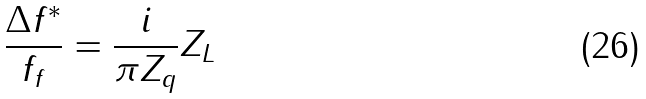Convert formula to latex. <formula><loc_0><loc_0><loc_500><loc_500>\frac { \Delta f ^ { * } } { f _ { f } } = \frac { i } { \pi Z _ { q } } Z _ { L }</formula> 